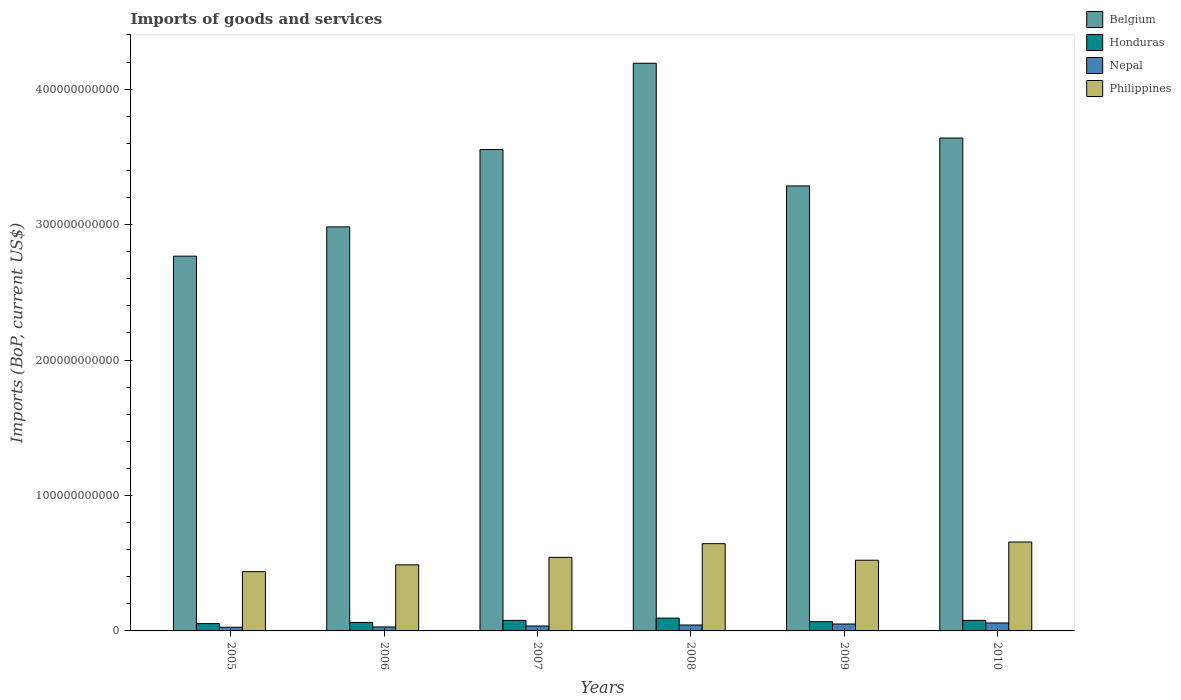How many different coloured bars are there?
Your answer should be compact. 4. How many groups of bars are there?
Give a very brief answer. 6. Are the number of bars per tick equal to the number of legend labels?
Your answer should be very brief. Yes. In how many cases, is the number of bars for a given year not equal to the number of legend labels?
Your answer should be very brief. 0. What is the amount spent on imports in Philippines in 2009?
Your response must be concise. 5.22e+1. Across all years, what is the maximum amount spent on imports in Philippines?
Your answer should be compact. 6.56e+1. Across all years, what is the minimum amount spent on imports in Honduras?
Provide a succinct answer. 5.40e+09. In which year was the amount spent on imports in Honduras maximum?
Your response must be concise. 2008. In which year was the amount spent on imports in Philippines minimum?
Make the answer very short. 2005. What is the total amount spent on imports in Nepal in the graph?
Your answer should be compact. 2.47e+1. What is the difference between the amount spent on imports in Philippines in 2005 and that in 2007?
Offer a terse response. -1.05e+1. What is the difference between the amount spent on imports in Philippines in 2010 and the amount spent on imports in Belgium in 2009?
Provide a succinct answer. -2.63e+11. What is the average amount spent on imports in Nepal per year?
Make the answer very short. 4.11e+09. In the year 2007, what is the difference between the amount spent on imports in Belgium and amount spent on imports in Philippines?
Your answer should be compact. 3.01e+11. In how many years, is the amount spent on imports in Philippines greater than 280000000000 US$?
Your answer should be compact. 0. What is the ratio of the amount spent on imports in Philippines in 2006 to that in 2007?
Your response must be concise. 0.9. What is the difference between the highest and the second highest amount spent on imports in Nepal?
Your answer should be very brief. 7.78e+08. What is the difference between the highest and the lowest amount spent on imports in Philippines?
Your answer should be compact. 2.19e+1. In how many years, is the amount spent on imports in Philippines greater than the average amount spent on imports in Philippines taken over all years?
Provide a succinct answer. 2. Is the sum of the amount spent on imports in Belgium in 2005 and 2009 greater than the maximum amount spent on imports in Honduras across all years?
Your answer should be very brief. Yes. What does the 3rd bar from the left in 2008 represents?
Offer a terse response. Nepal. Is it the case that in every year, the sum of the amount spent on imports in Honduras and amount spent on imports in Philippines is greater than the amount spent on imports in Belgium?
Provide a succinct answer. No. How many bars are there?
Give a very brief answer. 24. Are all the bars in the graph horizontal?
Provide a short and direct response. No. How many years are there in the graph?
Offer a terse response. 6. What is the difference between two consecutive major ticks on the Y-axis?
Your answer should be very brief. 1.00e+11. Does the graph contain any zero values?
Offer a very short reply. No. Does the graph contain grids?
Ensure brevity in your answer.  No. What is the title of the graph?
Provide a succinct answer. Imports of goods and services. Does "Niger" appear as one of the legend labels in the graph?
Your response must be concise. No. What is the label or title of the X-axis?
Your answer should be compact. Years. What is the label or title of the Y-axis?
Give a very brief answer. Imports (BoP, current US$). What is the Imports (BoP, current US$) of Belgium in 2005?
Your answer should be compact. 2.77e+11. What is the Imports (BoP, current US$) in Honduras in 2005?
Keep it short and to the point. 5.40e+09. What is the Imports (BoP, current US$) of Nepal in 2005?
Provide a succinct answer. 2.71e+09. What is the Imports (BoP, current US$) in Philippines in 2005?
Give a very brief answer. 4.38e+1. What is the Imports (BoP, current US$) of Belgium in 2006?
Ensure brevity in your answer.  2.98e+11. What is the Imports (BoP, current US$) in Honduras in 2006?
Offer a very short reply. 6.25e+09. What is the Imports (BoP, current US$) of Nepal in 2006?
Your response must be concise. 2.93e+09. What is the Imports (BoP, current US$) of Philippines in 2006?
Keep it short and to the point. 4.88e+1. What is the Imports (BoP, current US$) in Belgium in 2007?
Provide a succinct answer. 3.55e+11. What is the Imports (BoP, current US$) in Honduras in 2007?
Your answer should be very brief. 7.78e+09. What is the Imports (BoP, current US$) in Nepal in 2007?
Your response must be concise. 3.66e+09. What is the Imports (BoP, current US$) in Philippines in 2007?
Your answer should be very brief. 5.43e+1. What is the Imports (BoP, current US$) in Belgium in 2008?
Your answer should be very brief. 4.19e+11. What is the Imports (BoP, current US$) of Honduras in 2008?
Make the answer very short. 9.45e+09. What is the Imports (BoP, current US$) of Nepal in 2008?
Your answer should be very brief. 4.37e+09. What is the Imports (BoP, current US$) of Philippines in 2008?
Offer a terse response. 6.44e+1. What is the Imports (BoP, current US$) of Belgium in 2009?
Ensure brevity in your answer.  3.29e+11. What is the Imports (BoP, current US$) in Honduras in 2009?
Provide a succinct answer. 6.81e+09. What is the Imports (BoP, current US$) in Nepal in 2009?
Make the answer very short. 5.10e+09. What is the Imports (BoP, current US$) in Philippines in 2009?
Make the answer very short. 5.22e+1. What is the Imports (BoP, current US$) of Belgium in 2010?
Offer a very short reply. 3.64e+11. What is the Imports (BoP, current US$) of Honduras in 2010?
Ensure brevity in your answer.  7.78e+09. What is the Imports (BoP, current US$) of Nepal in 2010?
Your answer should be compact. 5.88e+09. What is the Imports (BoP, current US$) in Philippines in 2010?
Give a very brief answer. 6.56e+1. Across all years, what is the maximum Imports (BoP, current US$) in Belgium?
Your answer should be compact. 4.19e+11. Across all years, what is the maximum Imports (BoP, current US$) in Honduras?
Your answer should be very brief. 9.45e+09. Across all years, what is the maximum Imports (BoP, current US$) in Nepal?
Make the answer very short. 5.88e+09. Across all years, what is the maximum Imports (BoP, current US$) in Philippines?
Offer a very short reply. 6.56e+1. Across all years, what is the minimum Imports (BoP, current US$) of Belgium?
Ensure brevity in your answer.  2.77e+11. Across all years, what is the minimum Imports (BoP, current US$) in Honduras?
Your response must be concise. 5.40e+09. Across all years, what is the minimum Imports (BoP, current US$) in Nepal?
Your answer should be compact. 2.71e+09. Across all years, what is the minimum Imports (BoP, current US$) of Philippines?
Offer a terse response. 4.38e+1. What is the total Imports (BoP, current US$) of Belgium in the graph?
Your response must be concise. 2.04e+12. What is the total Imports (BoP, current US$) of Honduras in the graph?
Your answer should be very brief. 4.35e+1. What is the total Imports (BoP, current US$) in Nepal in the graph?
Provide a short and direct response. 2.47e+1. What is the total Imports (BoP, current US$) of Philippines in the graph?
Give a very brief answer. 3.29e+11. What is the difference between the Imports (BoP, current US$) of Belgium in 2005 and that in 2006?
Keep it short and to the point. -2.16e+1. What is the difference between the Imports (BoP, current US$) in Honduras in 2005 and that in 2006?
Offer a very short reply. -8.57e+08. What is the difference between the Imports (BoP, current US$) of Nepal in 2005 and that in 2006?
Give a very brief answer. -2.23e+08. What is the difference between the Imports (BoP, current US$) in Philippines in 2005 and that in 2006?
Give a very brief answer. -5.01e+09. What is the difference between the Imports (BoP, current US$) of Belgium in 2005 and that in 2007?
Provide a succinct answer. -7.87e+1. What is the difference between the Imports (BoP, current US$) of Honduras in 2005 and that in 2007?
Your answer should be compact. -2.38e+09. What is the difference between the Imports (BoP, current US$) of Nepal in 2005 and that in 2007?
Keep it short and to the point. -9.44e+08. What is the difference between the Imports (BoP, current US$) in Philippines in 2005 and that in 2007?
Your response must be concise. -1.05e+1. What is the difference between the Imports (BoP, current US$) of Belgium in 2005 and that in 2008?
Your response must be concise. -1.42e+11. What is the difference between the Imports (BoP, current US$) in Honduras in 2005 and that in 2008?
Provide a short and direct response. -4.05e+09. What is the difference between the Imports (BoP, current US$) of Nepal in 2005 and that in 2008?
Your response must be concise. -1.66e+09. What is the difference between the Imports (BoP, current US$) of Philippines in 2005 and that in 2008?
Provide a short and direct response. -2.06e+1. What is the difference between the Imports (BoP, current US$) of Belgium in 2005 and that in 2009?
Your answer should be very brief. -5.18e+1. What is the difference between the Imports (BoP, current US$) in Honduras in 2005 and that in 2009?
Your response must be concise. -1.41e+09. What is the difference between the Imports (BoP, current US$) of Nepal in 2005 and that in 2009?
Provide a succinct answer. -2.39e+09. What is the difference between the Imports (BoP, current US$) in Philippines in 2005 and that in 2009?
Give a very brief answer. -8.42e+09. What is the difference between the Imports (BoP, current US$) in Belgium in 2005 and that in 2010?
Your response must be concise. -8.72e+1. What is the difference between the Imports (BoP, current US$) of Honduras in 2005 and that in 2010?
Your response must be concise. -2.38e+09. What is the difference between the Imports (BoP, current US$) in Nepal in 2005 and that in 2010?
Offer a terse response. -3.17e+09. What is the difference between the Imports (BoP, current US$) of Philippines in 2005 and that in 2010?
Provide a short and direct response. -2.19e+1. What is the difference between the Imports (BoP, current US$) of Belgium in 2006 and that in 2007?
Your answer should be very brief. -5.71e+1. What is the difference between the Imports (BoP, current US$) in Honduras in 2006 and that in 2007?
Ensure brevity in your answer.  -1.52e+09. What is the difference between the Imports (BoP, current US$) of Nepal in 2006 and that in 2007?
Ensure brevity in your answer.  -7.21e+08. What is the difference between the Imports (BoP, current US$) in Philippines in 2006 and that in 2007?
Offer a very short reply. -5.53e+09. What is the difference between the Imports (BoP, current US$) in Belgium in 2006 and that in 2008?
Make the answer very short. -1.21e+11. What is the difference between the Imports (BoP, current US$) of Honduras in 2006 and that in 2008?
Your response must be concise. -3.19e+09. What is the difference between the Imports (BoP, current US$) of Nepal in 2006 and that in 2008?
Make the answer very short. -1.44e+09. What is the difference between the Imports (BoP, current US$) of Philippines in 2006 and that in 2008?
Provide a short and direct response. -1.56e+1. What is the difference between the Imports (BoP, current US$) in Belgium in 2006 and that in 2009?
Your response must be concise. -3.02e+1. What is the difference between the Imports (BoP, current US$) of Honduras in 2006 and that in 2009?
Your response must be concise. -5.55e+08. What is the difference between the Imports (BoP, current US$) of Nepal in 2006 and that in 2009?
Make the answer very short. -2.17e+09. What is the difference between the Imports (BoP, current US$) of Philippines in 2006 and that in 2009?
Make the answer very short. -3.41e+09. What is the difference between the Imports (BoP, current US$) in Belgium in 2006 and that in 2010?
Ensure brevity in your answer.  -6.56e+1. What is the difference between the Imports (BoP, current US$) of Honduras in 2006 and that in 2010?
Provide a short and direct response. -1.52e+09. What is the difference between the Imports (BoP, current US$) of Nepal in 2006 and that in 2010?
Offer a terse response. -2.94e+09. What is the difference between the Imports (BoP, current US$) in Philippines in 2006 and that in 2010?
Offer a very short reply. -1.69e+1. What is the difference between the Imports (BoP, current US$) of Belgium in 2007 and that in 2008?
Your answer should be compact. -6.37e+1. What is the difference between the Imports (BoP, current US$) in Honduras in 2007 and that in 2008?
Give a very brief answer. -1.67e+09. What is the difference between the Imports (BoP, current US$) of Nepal in 2007 and that in 2008?
Your response must be concise. -7.16e+08. What is the difference between the Imports (BoP, current US$) in Philippines in 2007 and that in 2008?
Provide a succinct answer. -1.01e+1. What is the difference between the Imports (BoP, current US$) in Belgium in 2007 and that in 2009?
Offer a terse response. 2.69e+1. What is the difference between the Imports (BoP, current US$) in Honduras in 2007 and that in 2009?
Give a very brief answer. 9.67e+08. What is the difference between the Imports (BoP, current US$) in Nepal in 2007 and that in 2009?
Provide a succinct answer. -1.45e+09. What is the difference between the Imports (BoP, current US$) in Philippines in 2007 and that in 2009?
Your answer should be compact. 2.12e+09. What is the difference between the Imports (BoP, current US$) of Belgium in 2007 and that in 2010?
Give a very brief answer. -8.51e+09. What is the difference between the Imports (BoP, current US$) in Honduras in 2007 and that in 2010?
Make the answer very short. 1.22e+06. What is the difference between the Imports (BoP, current US$) of Nepal in 2007 and that in 2010?
Offer a very short reply. -2.22e+09. What is the difference between the Imports (BoP, current US$) of Philippines in 2007 and that in 2010?
Offer a very short reply. -1.13e+1. What is the difference between the Imports (BoP, current US$) of Belgium in 2008 and that in 2009?
Keep it short and to the point. 9.06e+1. What is the difference between the Imports (BoP, current US$) in Honduras in 2008 and that in 2009?
Ensure brevity in your answer.  2.64e+09. What is the difference between the Imports (BoP, current US$) of Nepal in 2008 and that in 2009?
Give a very brief answer. -7.30e+08. What is the difference between the Imports (BoP, current US$) of Philippines in 2008 and that in 2009?
Your answer should be compact. 1.22e+1. What is the difference between the Imports (BoP, current US$) in Belgium in 2008 and that in 2010?
Offer a very short reply. 5.52e+1. What is the difference between the Imports (BoP, current US$) in Honduras in 2008 and that in 2010?
Provide a succinct answer. 1.67e+09. What is the difference between the Imports (BoP, current US$) of Nepal in 2008 and that in 2010?
Your response must be concise. -1.51e+09. What is the difference between the Imports (BoP, current US$) of Philippines in 2008 and that in 2010?
Make the answer very short. -1.24e+09. What is the difference between the Imports (BoP, current US$) in Belgium in 2009 and that in 2010?
Ensure brevity in your answer.  -3.54e+1. What is the difference between the Imports (BoP, current US$) of Honduras in 2009 and that in 2010?
Give a very brief answer. -9.66e+08. What is the difference between the Imports (BoP, current US$) in Nepal in 2009 and that in 2010?
Give a very brief answer. -7.78e+08. What is the difference between the Imports (BoP, current US$) in Philippines in 2009 and that in 2010?
Your answer should be very brief. -1.35e+1. What is the difference between the Imports (BoP, current US$) in Belgium in 2005 and the Imports (BoP, current US$) in Honduras in 2006?
Offer a terse response. 2.70e+11. What is the difference between the Imports (BoP, current US$) of Belgium in 2005 and the Imports (BoP, current US$) of Nepal in 2006?
Provide a succinct answer. 2.74e+11. What is the difference between the Imports (BoP, current US$) in Belgium in 2005 and the Imports (BoP, current US$) in Philippines in 2006?
Keep it short and to the point. 2.28e+11. What is the difference between the Imports (BoP, current US$) in Honduras in 2005 and the Imports (BoP, current US$) in Nepal in 2006?
Provide a short and direct response. 2.46e+09. What is the difference between the Imports (BoP, current US$) in Honduras in 2005 and the Imports (BoP, current US$) in Philippines in 2006?
Give a very brief answer. -4.34e+1. What is the difference between the Imports (BoP, current US$) of Nepal in 2005 and the Imports (BoP, current US$) of Philippines in 2006?
Your response must be concise. -4.61e+1. What is the difference between the Imports (BoP, current US$) in Belgium in 2005 and the Imports (BoP, current US$) in Honduras in 2007?
Your answer should be very brief. 2.69e+11. What is the difference between the Imports (BoP, current US$) of Belgium in 2005 and the Imports (BoP, current US$) of Nepal in 2007?
Your response must be concise. 2.73e+11. What is the difference between the Imports (BoP, current US$) of Belgium in 2005 and the Imports (BoP, current US$) of Philippines in 2007?
Ensure brevity in your answer.  2.22e+11. What is the difference between the Imports (BoP, current US$) of Honduras in 2005 and the Imports (BoP, current US$) of Nepal in 2007?
Ensure brevity in your answer.  1.74e+09. What is the difference between the Imports (BoP, current US$) of Honduras in 2005 and the Imports (BoP, current US$) of Philippines in 2007?
Give a very brief answer. -4.89e+1. What is the difference between the Imports (BoP, current US$) in Nepal in 2005 and the Imports (BoP, current US$) in Philippines in 2007?
Provide a succinct answer. -5.16e+1. What is the difference between the Imports (BoP, current US$) of Belgium in 2005 and the Imports (BoP, current US$) of Honduras in 2008?
Provide a short and direct response. 2.67e+11. What is the difference between the Imports (BoP, current US$) in Belgium in 2005 and the Imports (BoP, current US$) in Nepal in 2008?
Give a very brief answer. 2.72e+11. What is the difference between the Imports (BoP, current US$) of Belgium in 2005 and the Imports (BoP, current US$) of Philippines in 2008?
Your answer should be very brief. 2.12e+11. What is the difference between the Imports (BoP, current US$) in Honduras in 2005 and the Imports (BoP, current US$) in Nepal in 2008?
Keep it short and to the point. 1.03e+09. What is the difference between the Imports (BoP, current US$) in Honduras in 2005 and the Imports (BoP, current US$) in Philippines in 2008?
Offer a very short reply. -5.90e+1. What is the difference between the Imports (BoP, current US$) of Nepal in 2005 and the Imports (BoP, current US$) of Philippines in 2008?
Provide a succinct answer. -6.17e+1. What is the difference between the Imports (BoP, current US$) of Belgium in 2005 and the Imports (BoP, current US$) of Honduras in 2009?
Your answer should be compact. 2.70e+11. What is the difference between the Imports (BoP, current US$) of Belgium in 2005 and the Imports (BoP, current US$) of Nepal in 2009?
Your response must be concise. 2.72e+11. What is the difference between the Imports (BoP, current US$) of Belgium in 2005 and the Imports (BoP, current US$) of Philippines in 2009?
Provide a succinct answer. 2.24e+11. What is the difference between the Imports (BoP, current US$) in Honduras in 2005 and the Imports (BoP, current US$) in Nepal in 2009?
Keep it short and to the point. 2.96e+08. What is the difference between the Imports (BoP, current US$) of Honduras in 2005 and the Imports (BoP, current US$) of Philippines in 2009?
Offer a terse response. -4.68e+1. What is the difference between the Imports (BoP, current US$) in Nepal in 2005 and the Imports (BoP, current US$) in Philippines in 2009?
Make the answer very short. -4.95e+1. What is the difference between the Imports (BoP, current US$) of Belgium in 2005 and the Imports (BoP, current US$) of Honduras in 2010?
Provide a succinct answer. 2.69e+11. What is the difference between the Imports (BoP, current US$) in Belgium in 2005 and the Imports (BoP, current US$) in Nepal in 2010?
Your answer should be compact. 2.71e+11. What is the difference between the Imports (BoP, current US$) of Belgium in 2005 and the Imports (BoP, current US$) of Philippines in 2010?
Keep it short and to the point. 2.11e+11. What is the difference between the Imports (BoP, current US$) of Honduras in 2005 and the Imports (BoP, current US$) of Nepal in 2010?
Offer a terse response. -4.81e+08. What is the difference between the Imports (BoP, current US$) in Honduras in 2005 and the Imports (BoP, current US$) in Philippines in 2010?
Your answer should be compact. -6.03e+1. What is the difference between the Imports (BoP, current US$) of Nepal in 2005 and the Imports (BoP, current US$) of Philippines in 2010?
Provide a short and direct response. -6.29e+1. What is the difference between the Imports (BoP, current US$) in Belgium in 2006 and the Imports (BoP, current US$) in Honduras in 2007?
Your answer should be very brief. 2.91e+11. What is the difference between the Imports (BoP, current US$) in Belgium in 2006 and the Imports (BoP, current US$) in Nepal in 2007?
Offer a very short reply. 2.95e+11. What is the difference between the Imports (BoP, current US$) of Belgium in 2006 and the Imports (BoP, current US$) of Philippines in 2007?
Your answer should be compact. 2.44e+11. What is the difference between the Imports (BoP, current US$) of Honduras in 2006 and the Imports (BoP, current US$) of Nepal in 2007?
Make the answer very short. 2.60e+09. What is the difference between the Imports (BoP, current US$) of Honduras in 2006 and the Imports (BoP, current US$) of Philippines in 2007?
Ensure brevity in your answer.  -4.81e+1. What is the difference between the Imports (BoP, current US$) of Nepal in 2006 and the Imports (BoP, current US$) of Philippines in 2007?
Provide a succinct answer. -5.14e+1. What is the difference between the Imports (BoP, current US$) of Belgium in 2006 and the Imports (BoP, current US$) of Honduras in 2008?
Your response must be concise. 2.89e+11. What is the difference between the Imports (BoP, current US$) of Belgium in 2006 and the Imports (BoP, current US$) of Nepal in 2008?
Your response must be concise. 2.94e+11. What is the difference between the Imports (BoP, current US$) of Belgium in 2006 and the Imports (BoP, current US$) of Philippines in 2008?
Your answer should be very brief. 2.34e+11. What is the difference between the Imports (BoP, current US$) in Honduras in 2006 and the Imports (BoP, current US$) in Nepal in 2008?
Your answer should be very brief. 1.88e+09. What is the difference between the Imports (BoP, current US$) in Honduras in 2006 and the Imports (BoP, current US$) in Philippines in 2008?
Offer a terse response. -5.82e+1. What is the difference between the Imports (BoP, current US$) of Nepal in 2006 and the Imports (BoP, current US$) of Philippines in 2008?
Your answer should be compact. -6.15e+1. What is the difference between the Imports (BoP, current US$) in Belgium in 2006 and the Imports (BoP, current US$) in Honduras in 2009?
Keep it short and to the point. 2.91e+11. What is the difference between the Imports (BoP, current US$) in Belgium in 2006 and the Imports (BoP, current US$) in Nepal in 2009?
Keep it short and to the point. 2.93e+11. What is the difference between the Imports (BoP, current US$) of Belgium in 2006 and the Imports (BoP, current US$) of Philippines in 2009?
Ensure brevity in your answer.  2.46e+11. What is the difference between the Imports (BoP, current US$) of Honduras in 2006 and the Imports (BoP, current US$) of Nepal in 2009?
Give a very brief answer. 1.15e+09. What is the difference between the Imports (BoP, current US$) in Honduras in 2006 and the Imports (BoP, current US$) in Philippines in 2009?
Give a very brief answer. -4.59e+1. What is the difference between the Imports (BoP, current US$) of Nepal in 2006 and the Imports (BoP, current US$) of Philippines in 2009?
Your answer should be compact. -4.93e+1. What is the difference between the Imports (BoP, current US$) of Belgium in 2006 and the Imports (BoP, current US$) of Honduras in 2010?
Provide a short and direct response. 2.91e+11. What is the difference between the Imports (BoP, current US$) in Belgium in 2006 and the Imports (BoP, current US$) in Nepal in 2010?
Provide a succinct answer. 2.92e+11. What is the difference between the Imports (BoP, current US$) of Belgium in 2006 and the Imports (BoP, current US$) of Philippines in 2010?
Make the answer very short. 2.33e+11. What is the difference between the Imports (BoP, current US$) of Honduras in 2006 and the Imports (BoP, current US$) of Nepal in 2010?
Your response must be concise. 3.76e+08. What is the difference between the Imports (BoP, current US$) in Honduras in 2006 and the Imports (BoP, current US$) in Philippines in 2010?
Offer a terse response. -5.94e+1. What is the difference between the Imports (BoP, current US$) of Nepal in 2006 and the Imports (BoP, current US$) of Philippines in 2010?
Your answer should be very brief. -6.27e+1. What is the difference between the Imports (BoP, current US$) of Belgium in 2007 and the Imports (BoP, current US$) of Honduras in 2008?
Give a very brief answer. 3.46e+11. What is the difference between the Imports (BoP, current US$) in Belgium in 2007 and the Imports (BoP, current US$) in Nepal in 2008?
Offer a terse response. 3.51e+11. What is the difference between the Imports (BoP, current US$) in Belgium in 2007 and the Imports (BoP, current US$) in Philippines in 2008?
Provide a short and direct response. 2.91e+11. What is the difference between the Imports (BoP, current US$) in Honduras in 2007 and the Imports (BoP, current US$) in Nepal in 2008?
Offer a terse response. 3.41e+09. What is the difference between the Imports (BoP, current US$) in Honduras in 2007 and the Imports (BoP, current US$) in Philippines in 2008?
Your answer should be compact. -5.66e+1. What is the difference between the Imports (BoP, current US$) in Nepal in 2007 and the Imports (BoP, current US$) in Philippines in 2008?
Ensure brevity in your answer.  -6.08e+1. What is the difference between the Imports (BoP, current US$) of Belgium in 2007 and the Imports (BoP, current US$) of Honduras in 2009?
Provide a short and direct response. 3.49e+11. What is the difference between the Imports (BoP, current US$) of Belgium in 2007 and the Imports (BoP, current US$) of Nepal in 2009?
Offer a terse response. 3.50e+11. What is the difference between the Imports (BoP, current US$) in Belgium in 2007 and the Imports (BoP, current US$) in Philippines in 2009?
Provide a short and direct response. 3.03e+11. What is the difference between the Imports (BoP, current US$) of Honduras in 2007 and the Imports (BoP, current US$) of Nepal in 2009?
Provide a succinct answer. 2.68e+09. What is the difference between the Imports (BoP, current US$) of Honduras in 2007 and the Imports (BoP, current US$) of Philippines in 2009?
Give a very brief answer. -4.44e+1. What is the difference between the Imports (BoP, current US$) of Nepal in 2007 and the Imports (BoP, current US$) of Philippines in 2009?
Offer a terse response. -4.85e+1. What is the difference between the Imports (BoP, current US$) in Belgium in 2007 and the Imports (BoP, current US$) in Honduras in 2010?
Provide a short and direct response. 3.48e+11. What is the difference between the Imports (BoP, current US$) in Belgium in 2007 and the Imports (BoP, current US$) in Nepal in 2010?
Ensure brevity in your answer.  3.50e+11. What is the difference between the Imports (BoP, current US$) in Belgium in 2007 and the Imports (BoP, current US$) in Philippines in 2010?
Ensure brevity in your answer.  2.90e+11. What is the difference between the Imports (BoP, current US$) of Honduras in 2007 and the Imports (BoP, current US$) of Nepal in 2010?
Ensure brevity in your answer.  1.90e+09. What is the difference between the Imports (BoP, current US$) in Honduras in 2007 and the Imports (BoP, current US$) in Philippines in 2010?
Your answer should be compact. -5.79e+1. What is the difference between the Imports (BoP, current US$) of Nepal in 2007 and the Imports (BoP, current US$) of Philippines in 2010?
Offer a very short reply. -6.20e+1. What is the difference between the Imports (BoP, current US$) of Belgium in 2008 and the Imports (BoP, current US$) of Honduras in 2009?
Your response must be concise. 4.12e+11. What is the difference between the Imports (BoP, current US$) of Belgium in 2008 and the Imports (BoP, current US$) of Nepal in 2009?
Give a very brief answer. 4.14e+11. What is the difference between the Imports (BoP, current US$) of Belgium in 2008 and the Imports (BoP, current US$) of Philippines in 2009?
Provide a succinct answer. 3.67e+11. What is the difference between the Imports (BoP, current US$) in Honduras in 2008 and the Imports (BoP, current US$) in Nepal in 2009?
Give a very brief answer. 4.35e+09. What is the difference between the Imports (BoP, current US$) in Honduras in 2008 and the Imports (BoP, current US$) in Philippines in 2009?
Keep it short and to the point. -4.27e+1. What is the difference between the Imports (BoP, current US$) of Nepal in 2008 and the Imports (BoP, current US$) of Philippines in 2009?
Offer a very short reply. -4.78e+1. What is the difference between the Imports (BoP, current US$) of Belgium in 2008 and the Imports (BoP, current US$) of Honduras in 2010?
Give a very brief answer. 4.11e+11. What is the difference between the Imports (BoP, current US$) of Belgium in 2008 and the Imports (BoP, current US$) of Nepal in 2010?
Provide a short and direct response. 4.13e+11. What is the difference between the Imports (BoP, current US$) in Belgium in 2008 and the Imports (BoP, current US$) in Philippines in 2010?
Make the answer very short. 3.53e+11. What is the difference between the Imports (BoP, current US$) of Honduras in 2008 and the Imports (BoP, current US$) of Nepal in 2010?
Provide a succinct answer. 3.57e+09. What is the difference between the Imports (BoP, current US$) in Honduras in 2008 and the Imports (BoP, current US$) in Philippines in 2010?
Give a very brief answer. -5.62e+1. What is the difference between the Imports (BoP, current US$) of Nepal in 2008 and the Imports (BoP, current US$) of Philippines in 2010?
Give a very brief answer. -6.13e+1. What is the difference between the Imports (BoP, current US$) of Belgium in 2009 and the Imports (BoP, current US$) of Honduras in 2010?
Offer a terse response. 3.21e+11. What is the difference between the Imports (BoP, current US$) in Belgium in 2009 and the Imports (BoP, current US$) in Nepal in 2010?
Ensure brevity in your answer.  3.23e+11. What is the difference between the Imports (BoP, current US$) in Belgium in 2009 and the Imports (BoP, current US$) in Philippines in 2010?
Give a very brief answer. 2.63e+11. What is the difference between the Imports (BoP, current US$) of Honduras in 2009 and the Imports (BoP, current US$) of Nepal in 2010?
Offer a very short reply. 9.31e+08. What is the difference between the Imports (BoP, current US$) in Honduras in 2009 and the Imports (BoP, current US$) in Philippines in 2010?
Offer a very short reply. -5.88e+1. What is the difference between the Imports (BoP, current US$) of Nepal in 2009 and the Imports (BoP, current US$) of Philippines in 2010?
Ensure brevity in your answer.  -6.05e+1. What is the average Imports (BoP, current US$) in Belgium per year?
Provide a succinct answer. 3.40e+11. What is the average Imports (BoP, current US$) of Honduras per year?
Make the answer very short. 7.24e+09. What is the average Imports (BoP, current US$) of Nepal per year?
Your response must be concise. 4.11e+09. What is the average Imports (BoP, current US$) of Philippines per year?
Provide a succinct answer. 5.49e+1. In the year 2005, what is the difference between the Imports (BoP, current US$) of Belgium and Imports (BoP, current US$) of Honduras?
Keep it short and to the point. 2.71e+11. In the year 2005, what is the difference between the Imports (BoP, current US$) in Belgium and Imports (BoP, current US$) in Nepal?
Ensure brevity in your answer.  2.74e+11. In the year 2005, what is the difference between the Imports (BoP, current US$) of Belgium and Imports (BoP, current US$) of Philippines?
Make the answer very short. 2.33e+11. In the year 2005, what is the difference between the Imports (BoP, current US$) of Honduras and Imports (BoP, current US$) of Nepal?
Your answer should be very brief. 2.69e+09. In the year 2005, what is the difference between the Imports (BoP, current US$) in Honduras and Imports (BoP, current US$) in Philippines?
Make the answer very short. -3.84e+1. In the year 2005, what is the difference between the Imports (BoP, current US$) in Nepal and Imports (BoP, current US$) in Philippines?
Offer a terse response. -4.11e+1. In the year 2006, what is the difference between the Imports (BoP, current US$) of Belgium and Imports (BoP, current US$) of Honduras?
Your answer should be compact. 2.92e+11. In the year 2006, what is the difference between the Imports (BoP, current US$) in Belgium and Imports (BoP, current US$) in Nepal?
Your response must be concise. 2.95e+11. In the year 2006, what is the difference between the Imports (BoP, current US$) in Belgium and Imports (BoP, current US$) in Philippines?
Keep it short and to the point. 2.50e+11. In the year 2006, what is the difference between the Imports (BoP, current US$) in Honduras and Imports (BoP, current US$) in Nepal?
Keep it short and to the point. 3.32e+09. In the year 2006, what is the difference between the Imports (BoP, current US$) of Honduras and Imports (BoP, current US$) of Philippines?
Your response must be concise. -4.25e+1. In the year 2006, what is the difference between the Imports (BoP, current US$) in Nepal and Imports (BoP, current US$) in Philippines?
Ensure brevity in your answer.  -4.58e+1. In the year 2007, what is the difference between the Imports (BoP, current US$) in Belgium and Imports (BoP, current US$) in Honduras?
Make the answer very short. 3.48e+11. In the year 2007, what is the difference between the Imports (BoP, current US$) of Belgium and Imports (BoP, current US$) of Nepal?
Ensure brevity in your answer.  3.52e+11. In the year 2007, what is the difference between the Imports (BoP, current US$) in Belgium and Imports (BoP, current US$) in Philippines?
Keep it short and to the point. 3.01e+11. In the year 2007, what is the difference between the Imports (BoP, current US$) of Honduras and Imports (BoP, current US$) of Nepal?
Offer a very short reply. 4.12e+09. In the year 2007, what is the difference between the Imports (BoP, current US$) in Honduras and Imports (BoP, current US$) in Philippines?
Ensure brevity in your answer.  -4.65e+1. In the year 2007, what is the difference between the Imports (BoP, current US$) of Nepal and Imports (BoP, current US$) of Philippines?
Keep it short and to the point. -5.07e+1. In the year 2008, what is the difference between the Imports (BoP, current US$) in Belgium and Imports (BoP, current US$) in Honduras?
Your answer should be compact. 4.10e+11. In the year 2008, what is the difference between the Imports (BoP, current US$) of Belgium and Imports (BoP, current US$) of Nepal?
Offer a terse response. 4.15e+11. In the year 2008, what is the difference between the Imports (BoP, current US$) of Belgium and Imports (BoP, current US$) of Philippines?
Provide a short and direct response. 3.55e+11. In the year 2008, what is the difference between the Imports (BoP, current US$) in Honduras and Imports (BoP, current US$) in Nepal?
Provide a short and direct response. 5.08e+09. In the year 2008, what is the difference between the Imports (BoP, current US$) in Honduras and Imports (BoP, current US$) in Philippines?
Ensure brevity in your answer.  -5.50e+1. In the year 2008, what is the difference between the Imports (BoP, current US$) of Nepal and Imports (BoP, current US$) of Philippines?
Make the answer very short. -6.00e+1. In the year 2009, what is the difference between the Imports (BoP, current US$) in Belgium and Imports (BoP, current US$) in Honduras?
Make the answer very short. 3.22e+11. In the year 2009, what is the difference between the Imports (BoP, current US$) in Belgium and Imports (BoP, current US$) in Nepal?
Your answer should be compact. 3.23e+11. In the year 2009, what is the difference between the Imports (BoP, current US$) of Belgium and Imports (BoP, current US$) of Philippines?
Your answer should be compact. 2.76e+11. In the year 2009, what is the difference between the Imports (BoP, current US$) of Honduras and Imports (BoP, current US$) of Nepal?
Offer a terse response. 1.71e+09. In the year 2009, what is the difference between the Imports (BoP, current US$) in Honduras and Imports (BoP, current US$) in Philippines?
Provide a short and direct response. -4.54e+1. In the year 2009, what is the difference between the Imports (BoP, current US$) of Nepal and Imports (BoP, current US$) of Philippines?
Your answer should be very brief. -4.71e+1. In the year 2010, what is the difference between the Imports (BoP, current US$) of Belgium and Imports (BoP, current US$) of Honduras?
Provide a succinct answer. 3.56e+11. In the year 2010, what is the difference between the Imports (BoP, current US$) in Belgium and Imports (BoP, current US$) in Nepal?
Provide a succinct answer. 3.58e+11. In the year 2010, what is the difference between the Imports (BoP, current US$) in Belgium and Imports (BoP, current US$) in Philippines?
Make the answer very short. 2.98e+11. In the year 2010, what is the difference between the Imports (BoP, current US$) in Honduras and Imports (BoP, current US$) in Nepal?
Keep it short and to the point. 1.90e+09. In the year 2010, what is the difference between the Imports (BoP, current US$) of Honduras and Imports (BoP, current US$) of Philippines?
Make the answer very short. -5.79e+1. In the year 2010, what is the difference between the Imports (BoP, current US$) in Nepal and Imports (BoP, current US$) in Philippines?
Ensure brevity in your answer.  -5.98e+1. What is the ratio of the Imports (BoP, current US$) in Belgium in 2005 to that in 2006?
Your answer should be compact. 0.93. What is the ratio of the Imports (BoP, current US$) in Honduras in 2005 to that in 2006?
Provide a short and direct response. 0.86. What is the ratio of the Imports (BoP, current US$) in Nepal in 2005 to that in 2006?
Offer a very short reply. 0.92. What is the ratio of the Imports (BoP, current US$) of Philippines in 2005 to that in 2006?
Keep it short and to the point. 0.9. What is the ratio of the Imports (BoP, current US$) of Belgium in 2005 to that in 2007?
Provide a succinct answer. 0.78. What is the ratio of the Imports (BoP, current US$) of Honduras in 2005 to that in 2007?
Give a very brief answer. 0.69. What is the ratio of the Imports (BoP, current US$) of Nepal in 2005 to that in 2007?
Give a very brief answer. 0.74. What is the ratio of the Imports (BoP, current US$) in Philippines in 2005 to that in 2007?
Provide a succinct answer. 0.81. What is the ratio of the Imports (BoP, current US$) in Belgium in 2005 to that in 2008?
Provide a short and direct response. 0.66. What is the ratio of the Imports (BoP, current US$) in Honduras in 2005 to that in 2008?
Offer a terse response. 0.57. What is the ratio of the Imports (BoP, current US$) in Nepal in 2005 to that in 2008?
Offer a very short reply. 0.62. What is the ratio of the Imports (BoP, current US$) in Philippines in 2005 to that in 2008?
Your answer should be compact. 0.68. What is the ratio of the Imports (BoP, current US$) of Belgium in 2005 to that in 2009?
Give a very brief answer. 0.84. What is the ratio of the Imports (BoP, current US$) of Honduras in 2005 to that in 2009?
Keep it short and to the point. 0.79. What is the ratio of the Imports (BoP, current US$) in Nepal in 2005 to that in 2009?
Your response must be concise. 0.53. What is the ratio of the Imports (BoP, current US$) in Philippines in 2005 to that in 2009?
Provide a short and direct response. 0.84. What is the ratio of the Imports (BoP, current US$) in Belgium in 2005 to that in 2010?
Offer a terse response. 0.76. What is the ratio of the Imports (BoP, current US$) of Honduras in 2005 to that in 2010?
Your response must be concise. 0.69. What is the ratio of the Imports (BoP, current US$) of Nepal in 2005 to that in 2010?
Your answer should be very brief. 0.46. What is the ratio of the Imports (BoP, current US$) of Belgium in 2006 to that in 2007?
Keep it short and to the point. 0.84. What is the ratio of the Imports (BoP, current US$) of Honduras in 2006 to that in 2007?
Keep it short and to the point. 0.8. What is the ratio of the Imports (BoP, current US$) in Nepal in 2006 to that in 2007?
Provide a succinct answer. 0.8. What is the ratio of the Imports (BoP, current US$) in Philippines in 2006 to that in 2007?
Offer a very short reply. 0.9. What is the ratio of the Imports (BoP, current US$) in Belgium in 2006 to that in 2008?
Your response must be concise. 0.71. What is the ratio of the Imports (BoP, current US$) in Honduras in 2006 to that in 2008?
Your response must be concise. 0.66. What is the ratio of the Imports (BoP, current US$) in Nepal in 2006 to that in 2008?
Provide a short and direct response. 0.67. What is the ratio of the Imports (BoP, current US$) of Philippines in 2006 to that in 2008?
Your answer should be compact. 0.76. What is the ratio of the Imports (BoP, current US$) of Belgium in 2006 to that in 2009?
Your answer should be compact. 0.91. What is the ratio of the Imports (BoP, current US$) in Honduras in 2006 to that in 2009?
Your answer should be compact. 0.92. What is the ratio of the Imports (BoP, current US$) of Nepal in 2006 to that in 2009?
Offer a very short reply. 0.58. What is the ratio of the Imports (BoP, current US$) of Philippines in 2006 to that in 2009?
Your answer should be compact. 0.93. What is the ratio of the Imports (BoP, current US$) of Belgium in 2006 to that in 2010?
Offer a very short reply. 0.82. What is the ratio of the Imports (BoP, current US$) of Honduras in 2006 to that in 2010?
Your response must be concise. 0.8. What is the ratio of the Imports (BoP, current US$) in Nepal in 2006 to that in 2010?
Provide a short and direct response. 0.5. What is the ratio of the Imports (BoP, current US$) in Philippines in 2006 to that in 2010?
Offer a terse response. 0.74. What is the ratio of the Imports (BoP, current US$) of Belgium in 2007 to that in 2008?
Offer a terse response. 0.85. What is the ratio of the Imports (BoP, current US$) of Honduras in 2007 to that in 2008?
Your answer should be very brief. 0.82. What is the ratio of the Imports (BoP, current US$) of Nepal in 2007 to that in 2008?
Offer a very short reply. 0.84. What is the ratio of the Imports (BoP, current US$) in Philippines in 2007 to that in 2008?
Make the answer very short. 0.84. What is the ratio of the Imports (BoP, current US$) of Belgium in 2007 to that in 2009?
Offer a very short reply. 1.08. What is the ratio of the Imports (BoP, current US$) of Honduras in 2007 to that in 2009?
Provide a short and direct response. 1.14. What is the ratio of the Imports (BoP, current US$) of Nepal in 2007 to that in 2009?
Provide a succinct answer. 0.72. What is the ratio of the Imports (BoP, current US$) of Philippines in 2007 to that in 2009?
Keep it short and to the point. 1.04. What is the ratio of the Imports (BoP, current US$) of Belgium in 2007 to that in 2010?
Your answer should be compact. 0.98. What is the ratio of the Imports (BoP, current US$) in Honduras in 2007 to that in 2010?
Make the answer very short. 1. What is the ratio of the Imports (BoP, current US$) in Nepal in 2007 to that in 2010?
Your answer should be compact. 0.62. What is the ratio of the Imports (BoP, current US$) in Philippines in 2007 to that in 2010?
Make the answer very short. 0.83. What is the ratio of the Imports (BoP, current US$) in Belgium in 2008 to that in 2009?
Your response must be concise. 1.28. What is the ratio of the Imports (BoP, current US$) in Honduras in 2008 to that in 2009?
Make the answer very short. 1.39. What is the ratio of the Imports (BoP, current US$) in Nepal in 2008 to that in 2009?
Ensure brevity in your answer.  0.86. What is the ratio of the Imports (BoP, current US$) in Philippines in 2008 to that in 2009?
Keep it short and to the point. 1.23. What is the ratio of the Imports (BoP, current US$) of Belgium in 2008 to that in 2010?
Provide a short and direct response. 1.15. What is the ratio of the Imports (BoP, current US$) in Honduras in 2008 to that in 2010?
Give a very brief answer. 1.22. What is the ratio of the Imports (BoP, current US$) in Nepal in 2008 to that in 2010?
Provide a short and direct response. 0.74. What is the ratio of the Imports (BoP, current US$) in Philippines in 2008 to that in 2010?
Keep it short and to the point. 0.98. What is the ratio of the Imports (BoP, current US$) in Belgium in 2009 to that in 2010?
Offer a terse response. 0.9. What is the ratio of the Imports (BoP, current US$) of Honduras in 2009 to that in 2010?
Keep it short and to the point. 0.88. What is the ratio of the Imports (BoP, current US$) in Nepal in 2009 to that in 2010?
Your answer should be compact. 0.87. What is the ratio of the Imports (BoP, current US$) in Philippines in 2009 to that in 2010?
Your answer should be compact. 0.8. What is the difference between the highest and the second highest Imports (BoP, current US$) of Belgium?
Offer a very short reply. 5.52e+1. What is the difference between the highest and the second highest Imports (BoP, current US$) in Honduras?
Ensure brevity in your answer.  1.67e+09. What is the difference between the highest and the second highest Imports (BoP, current US$) in Nepal?
Provide a succinct answer. 7.78e+08. What is the difference between the highest and the second highest Imports (BoP, current US$) of Philippines?
Keep it short and to the point. 1.24e+09. What is the difference between the highest and the lowest Imports (BoP, current US$) in Belgium?
Your answer should be compact. 1.42e+11. What is the difference between the highest and the lowest Imports (BoP, current US$) in Honduras?
Offer a terse response. 4.05e+09. What is the difference between the highest and the lowest Imports (BoP, current US$) of Nepal?
Offer a terse response. 3.17e+09. What is the difference between the highest and the lowest Imports (BoP, current US$) in Philippines?
Provide a short and direct response. 2.19e+1. 